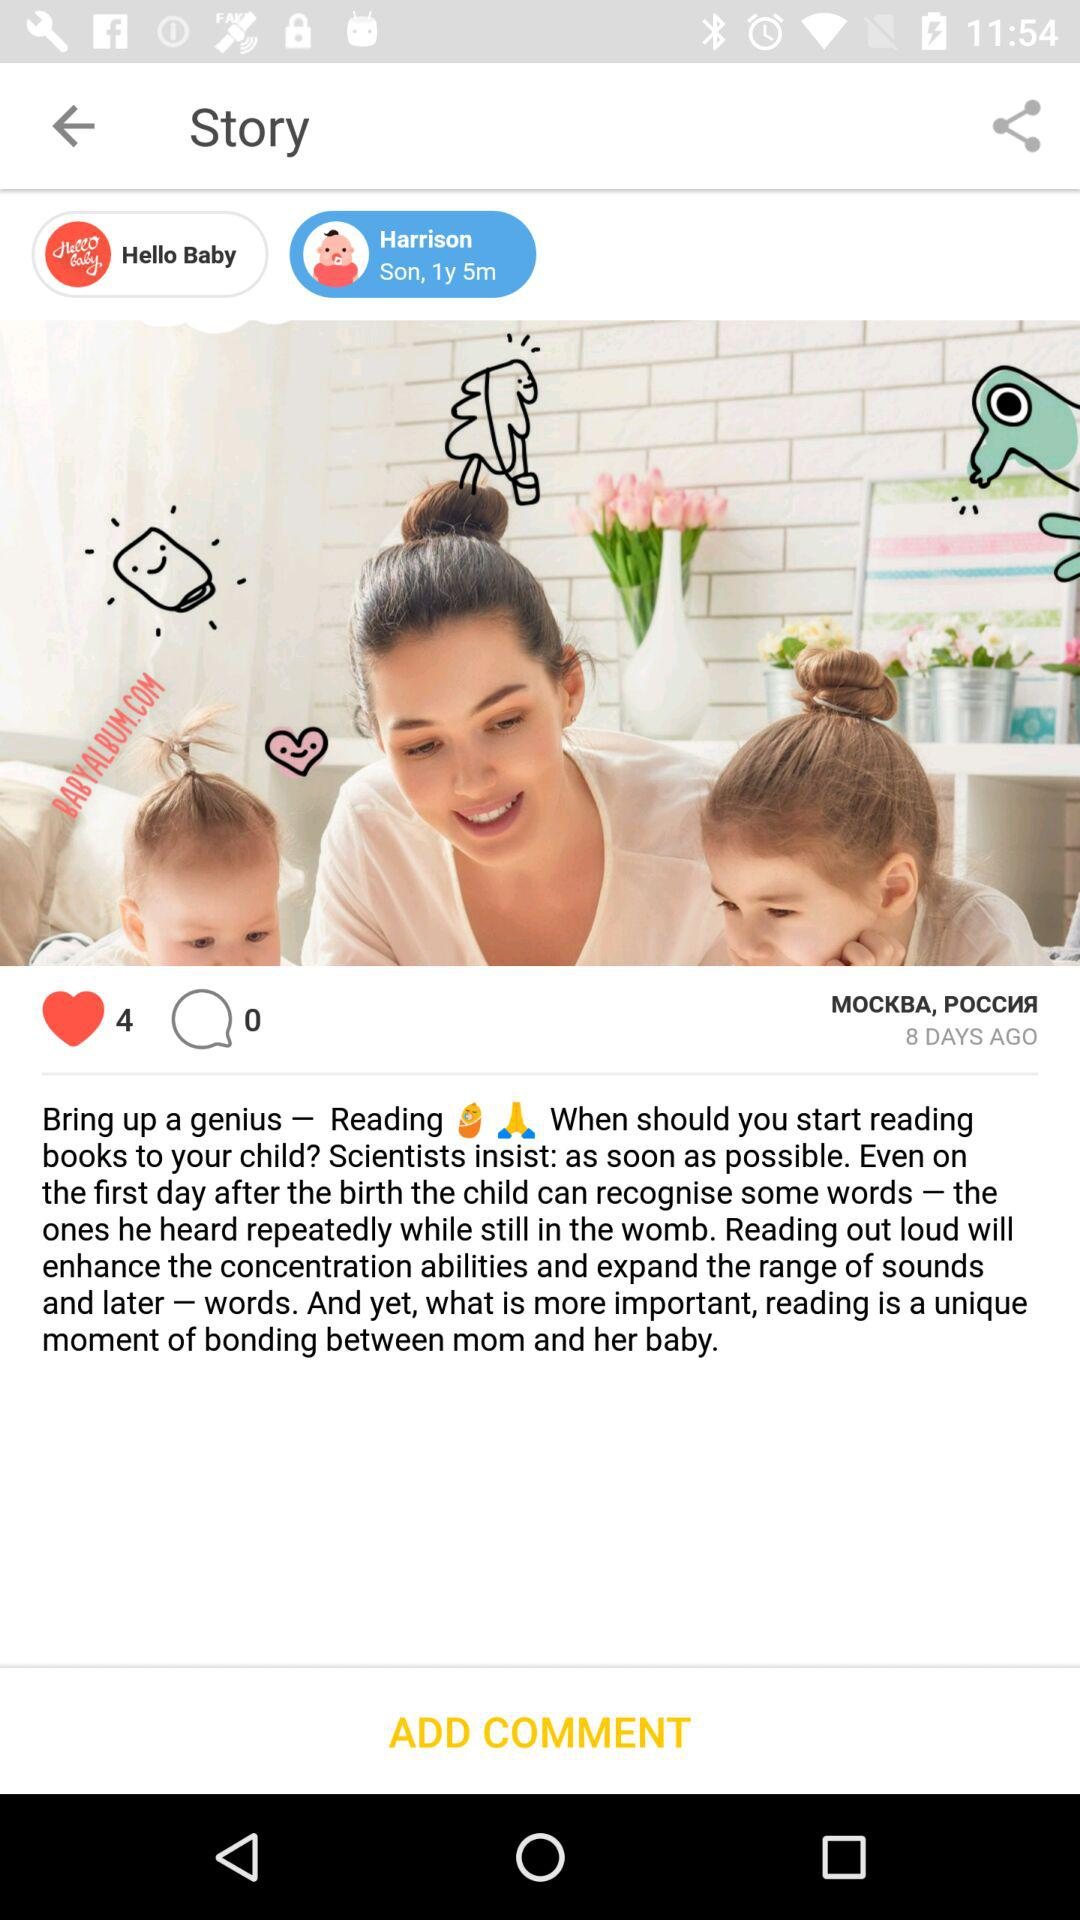How many total likes on the post? There are 4 likes on the post. 